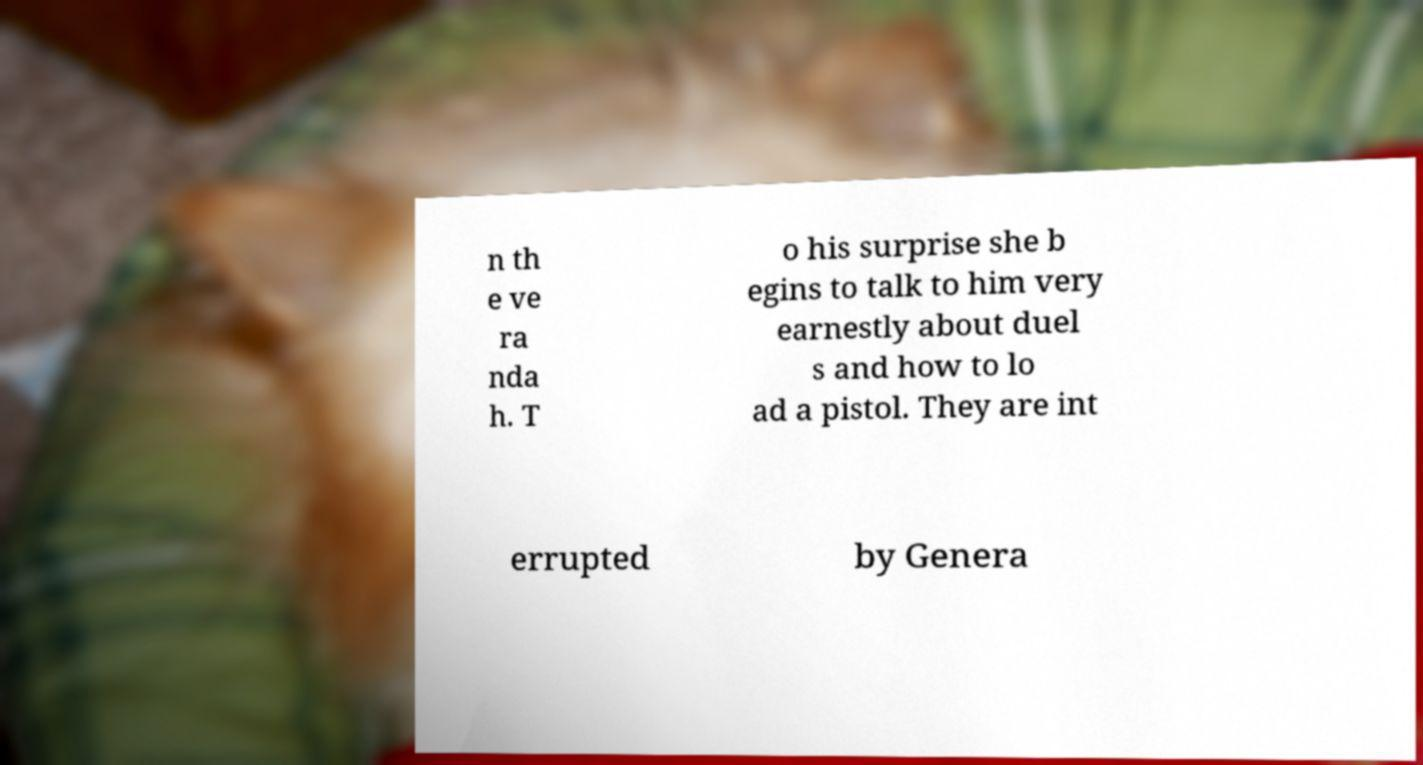Please read and relay the text visible in this image. What does it say? n th e ve ra nda h. T o his surprise she b egins to talk to him very earnestly about duel s and how to lo ad a pistol. They are int errupted by Genera 